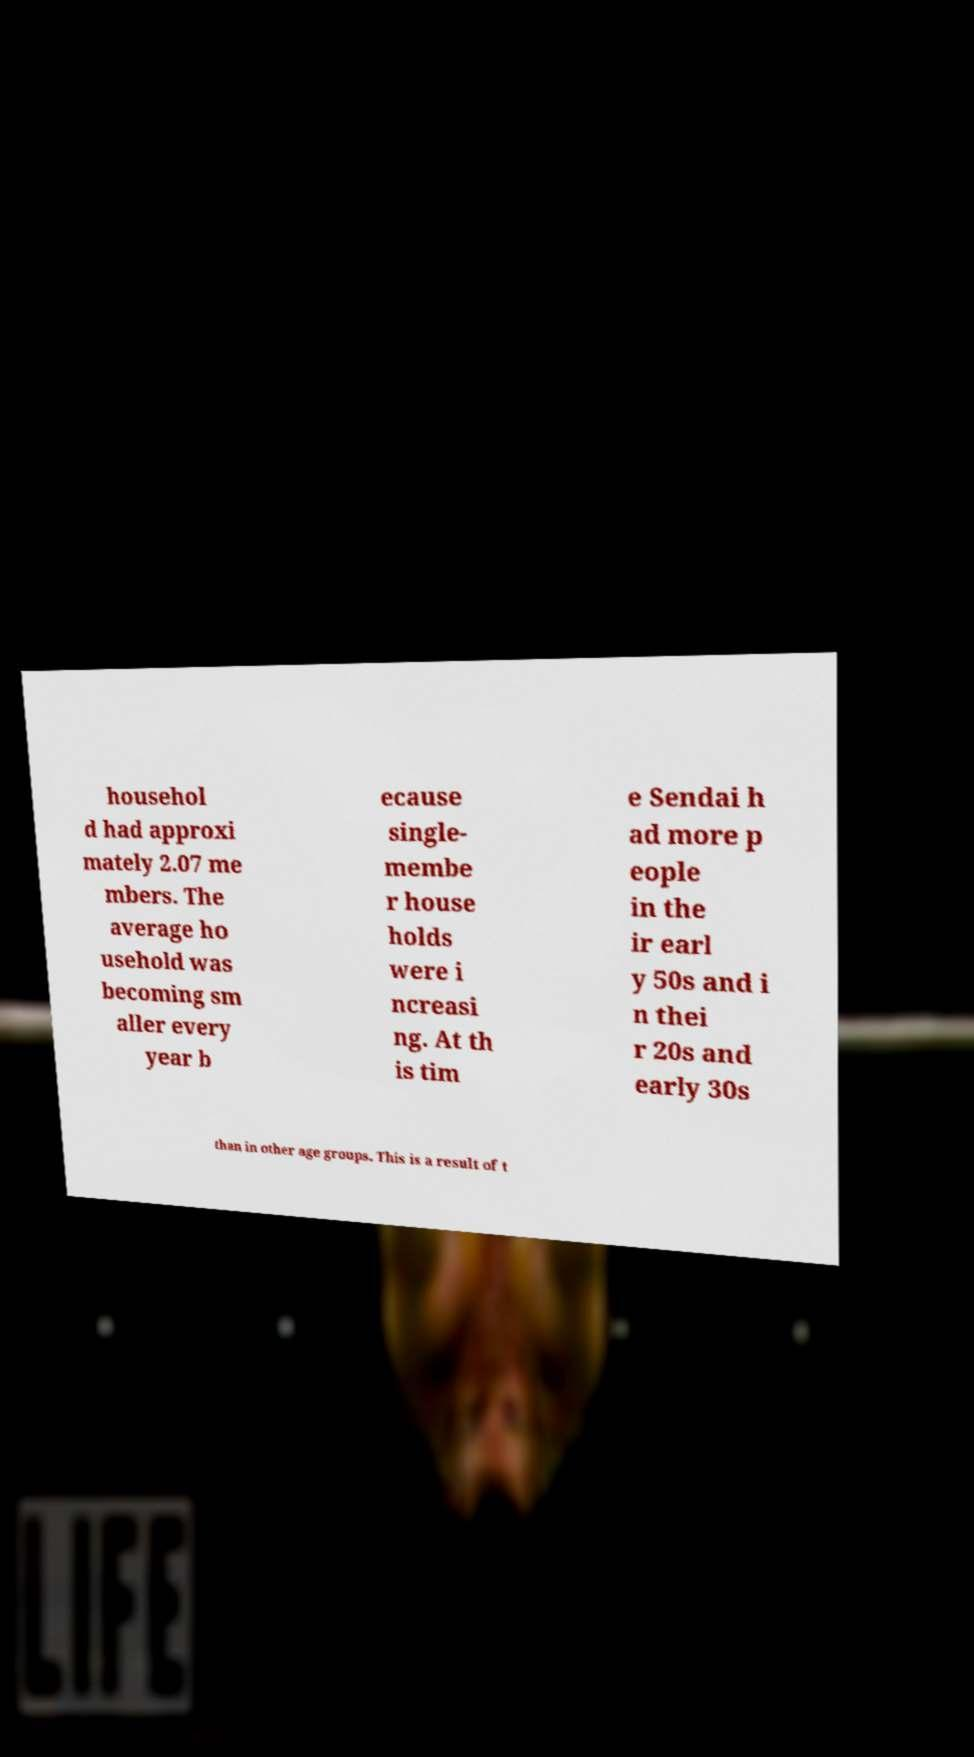Please read and relay the text visible in this image. What does it say? househol d had approxi mately 2.07 me mbers. The average ho usehold was becoming sm aller every year b ecause single- membe r house holds were i ncreasi ng. At th is tim e Sendai h ad more p eople in the ir earl y 50s and i n thei r 20s and early 30s than in other age groups. This is a result of t 